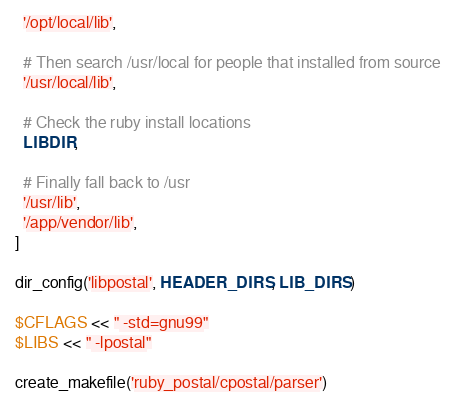Convert code to text. <code><loc_0><loc_0><loc_500><loc_500><_Ruby_>  '/opt/local/lib',

  # Then search /usr/local for people that installed from source
  '/usr/local/lib',

  # Check the ruby install locations
  LIBDIR,

  # Finally fall back to /usr
  '/usr/lib',
  '/app/vendor/lib',
]

dir_config('libpostal', HEADER_DIRS, LIB_DIRS)

$CFLAGS << " -std=gnu99"
$LIBS << " -lpostal"

create_makefile('ruby_postal/cpostal/parser')
</code> 